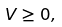<formula> <loc_0><loc_0><loc_500><loc_500>V \geq 0 ,</formula> 